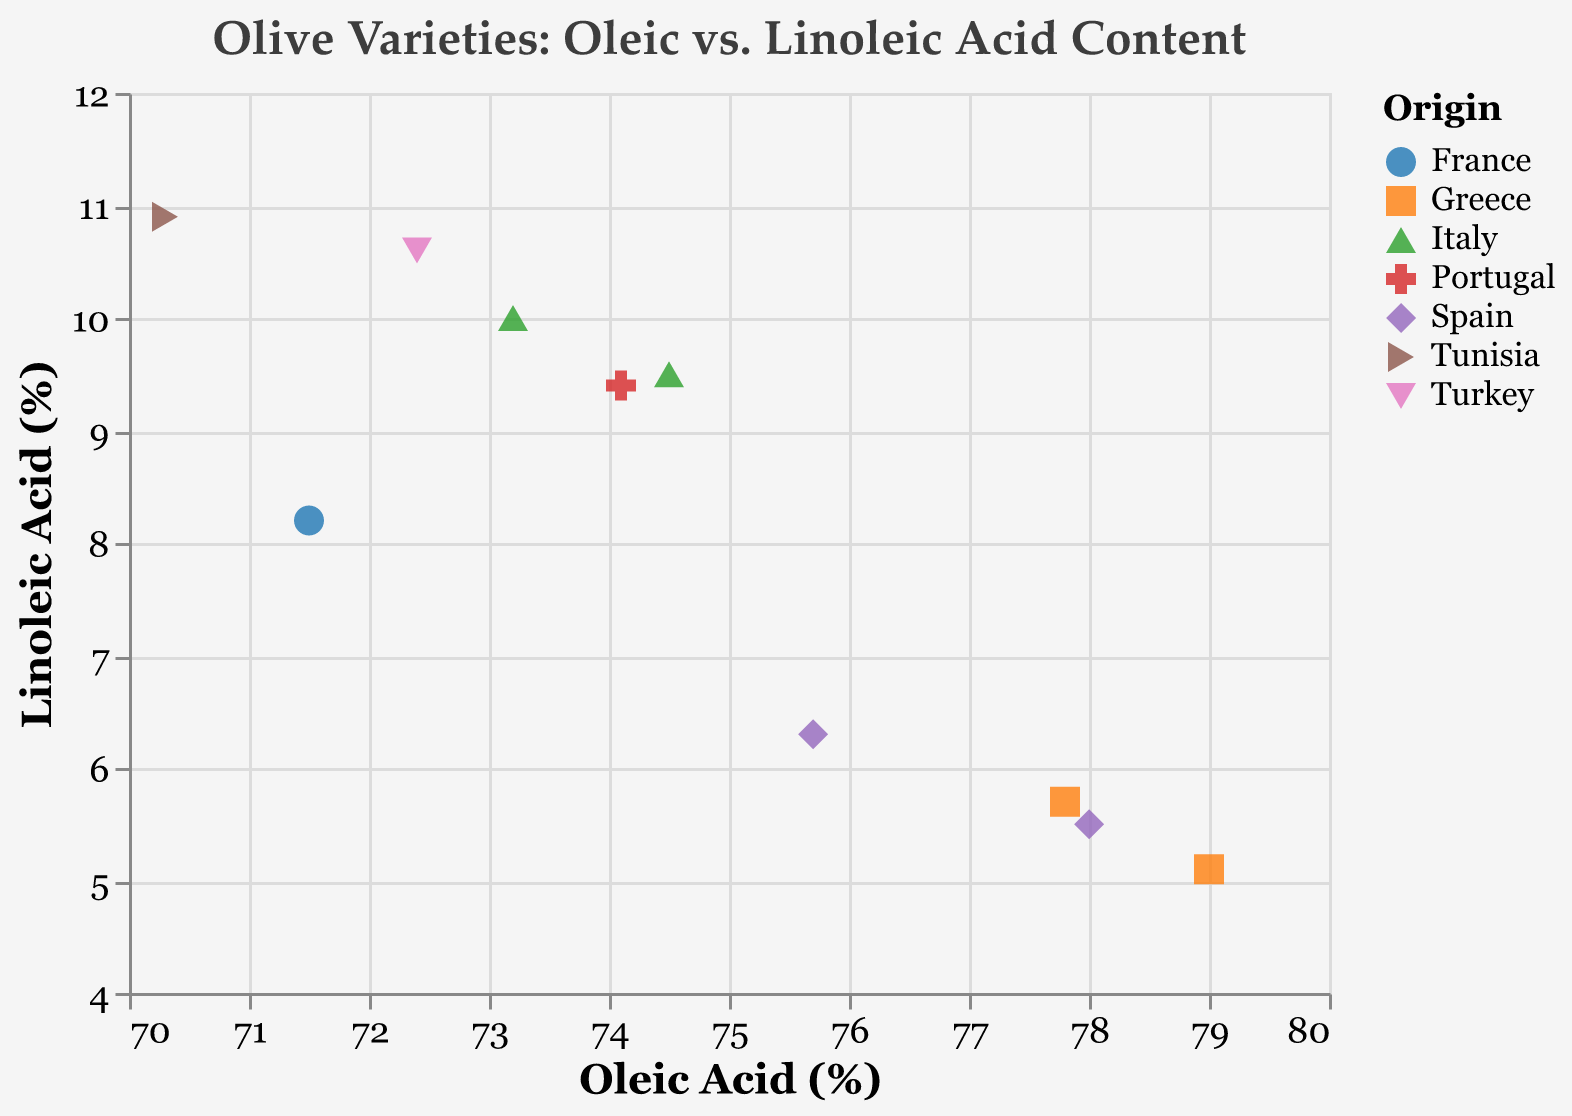How many olive varieties are displayed in the figure? Count the total number of data points represented by different markers. Each marker corresponds to an olive variety.
Answer: 10 Which country has the most diverse oleic acid content in its olive varieties? Look at the markers colored differently for each country and compare the range of oleic acid (%) values shown on the x-axis.
Answer: Spain Are there any olive varieties from Greece with higher linoleic acid content than an olive variety from Turkey? Compare the linoleic acid (%) on the y-axis of varieties from Greece (Koroneiki and Athinolia) and Turkey (Memecik). Koroneiki (5.1%) and Athinolia (5.7%) have lower linoleic acid than Memecik (10.6%).
Answer: No Among olive varieties from Italy, which one has the highest oleic acid content and what is that value? Identify Italian varieties (Frantoio and Leccino) and compare their oleic acid (%) values shown on the x-axis.
Answer: Frantoio, 74.5% What is the average linoleic acid content for the olive varieties from Spain? Identify Spanish varieties (Picual, Hojiblanca) and calculate the average of their linoleic acid (%) values: \( (5.5 + 6.3) / 2 = 5.9 \).
Answer: 5.9% Is there any variety with more than 78% oleic acid content? Check the oleic acid (%) on the x-axis and find any data points exceeding 78%. The only variety is Koroneiki (79.0%).
Answer: Yes, Koroneiki Which olive variety has the lowest palmitic acid content among all the varieties? Observe the tooltip information to find the variety with the lowest palmitic acid (%) value.
Answer: Frantoio, 10.2% Which country's olive varieties generally have the highest linoleic acid content? Compare the linoleic acid (%) across different origins using the y-axis. Tunisia (Chetoui) stands out with 10.9%.
Answer: Tunisia What is the difference in oleic acid content between the varieties 'Picual' and 'Chetoui'? Subtract the oleic acid (%) value of Chetoui (70.3%) from Picual (78.0%): \( 78.0 - 70.3 = 7.7 \).
Answer: 7.7% Are the olive varieties from France and Portugal more similar in terms of oleic acid content or linoleic acid content? Compare the oleic and linoleic acid (%) values for France (Picholine) and Portugal (Galega). Oleic: 71.5% and 74.1%, respectively. Linoleic: 8.2% and 9.4%, respectively. The oleic acid values are closer (74.1% - 71.5% = 2.6%) than the linoleic acid values (9.4% - 8.2% = 1.2%).
Answer: Linoleic acid 